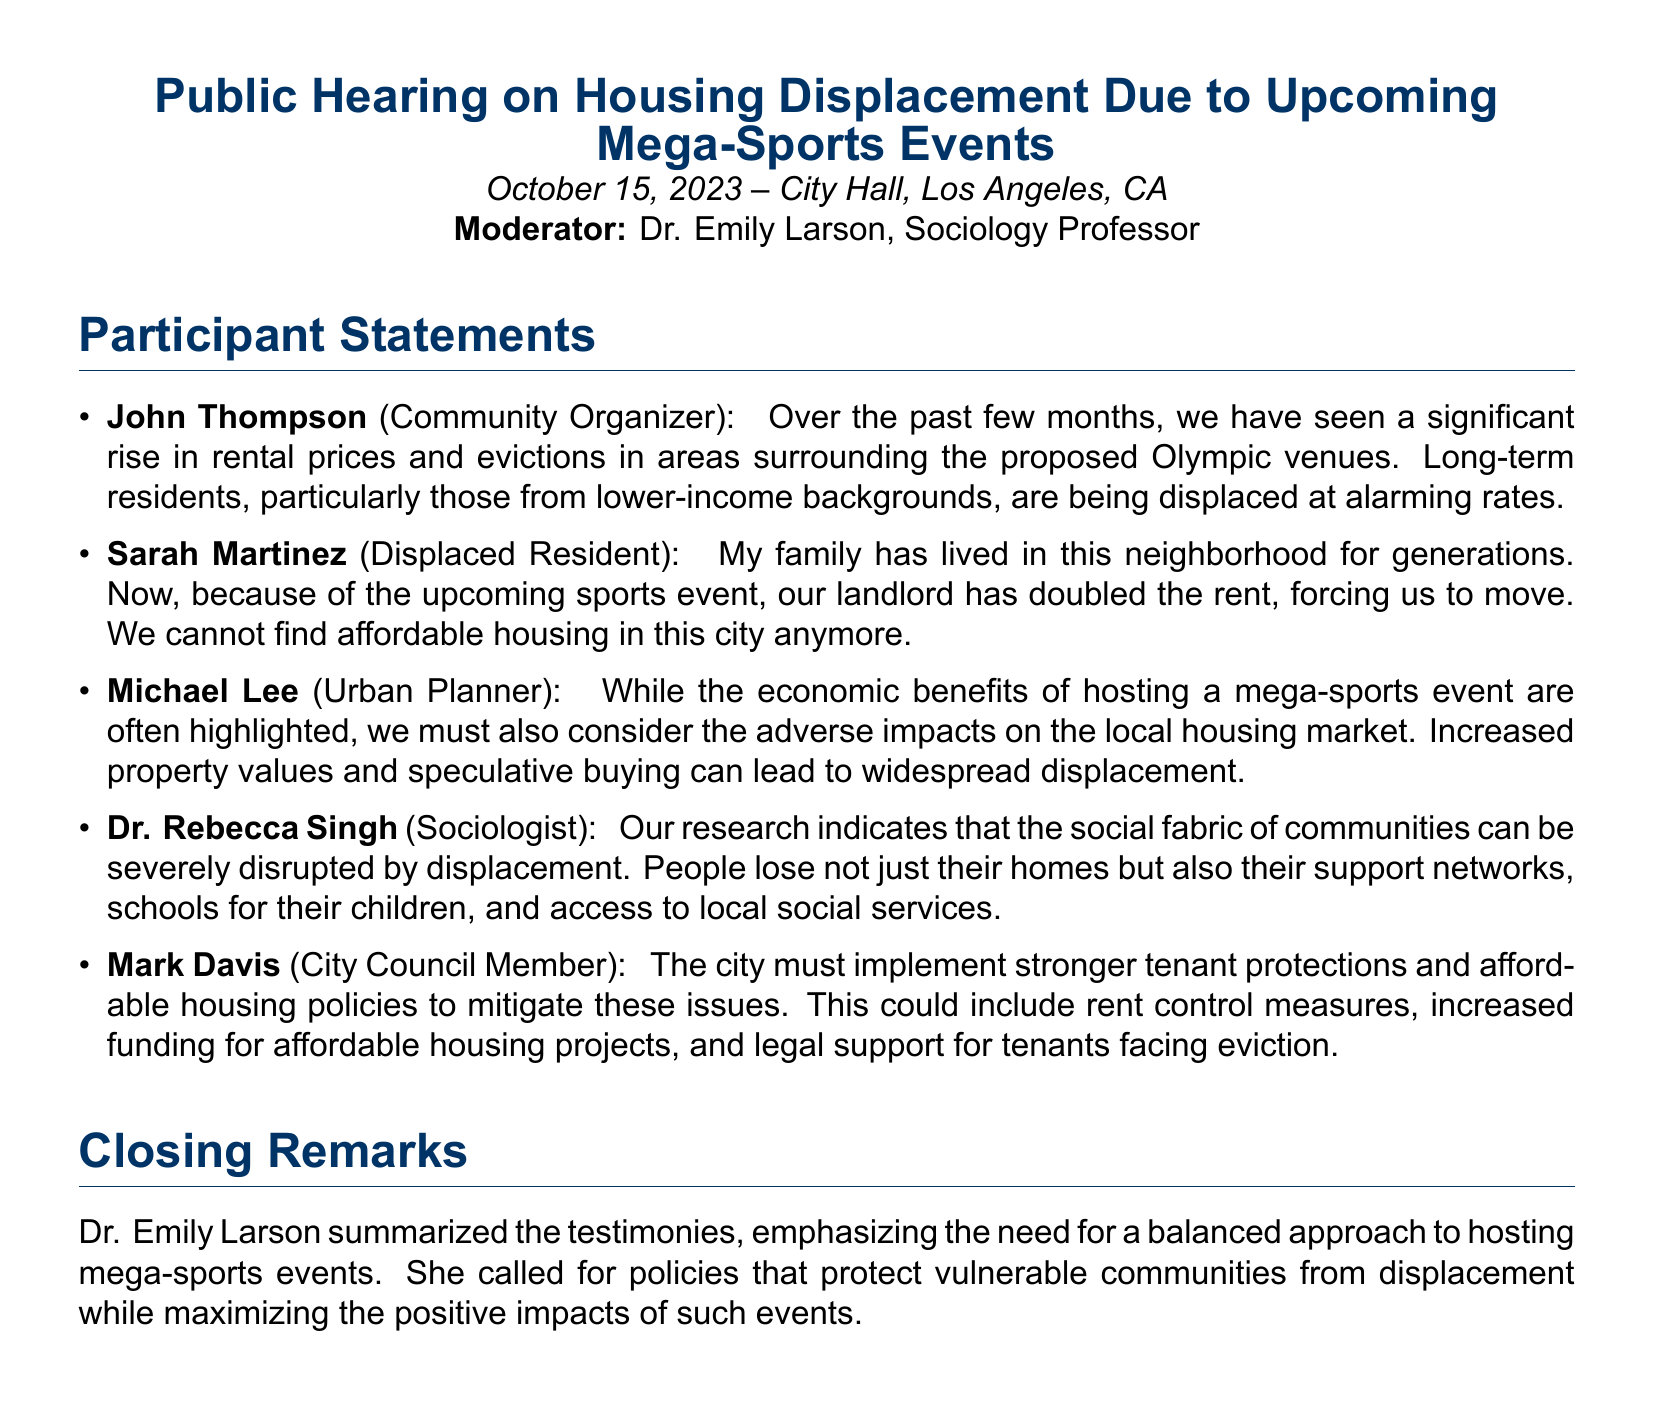what event is being discussed in the public hearing? The document discusses the upcoming mega-sports events, specifically the Olympics.
Answer: mega-sports events who is the moderator of the public hearing? The moderator is Dr. Emily Larson, a Sociology Professor.
Answer: Dr. Emily Larson which resident mentioned being forced to move due to increased rent? Sarah Martinez, a displaced resident, talked about her family's situation regarding rent increases.
Answer: Sarah Martinez what did John Thompson highlight as a consequence of the upcoming events? He emphasized the significant rise in rental prices and evictions in the surrounding areas.
Answer: rental prices and evictions what is one suggestion made by Mark Davis to address the issues discussed? Mark Davis suggested implementing stronger tenant protections and affordable housing policies.
Answer: stronger tenant protections what disruption does Dr. Rebecca Singh associate with housing displacement? She associates the loss of support networks, schools, and access to services as disruptions caused by displacement.
Answer: support networks how does Michael Lee characterize the economic benefits of hosting the event? He indicates that while the benefits are often highlighted, adverse impacts on housing must also be considered.
Answer: adverse impacts on housing when did the public hearing take place? The public hearing occurred on October 15, 2023.
Answer: October 15, 2023 which group is primarily affected by the housing issues discussed? Long-term residents, particularly from lower-income backgrounds, are primarily affected.
Answer: lower-income backgrounds 